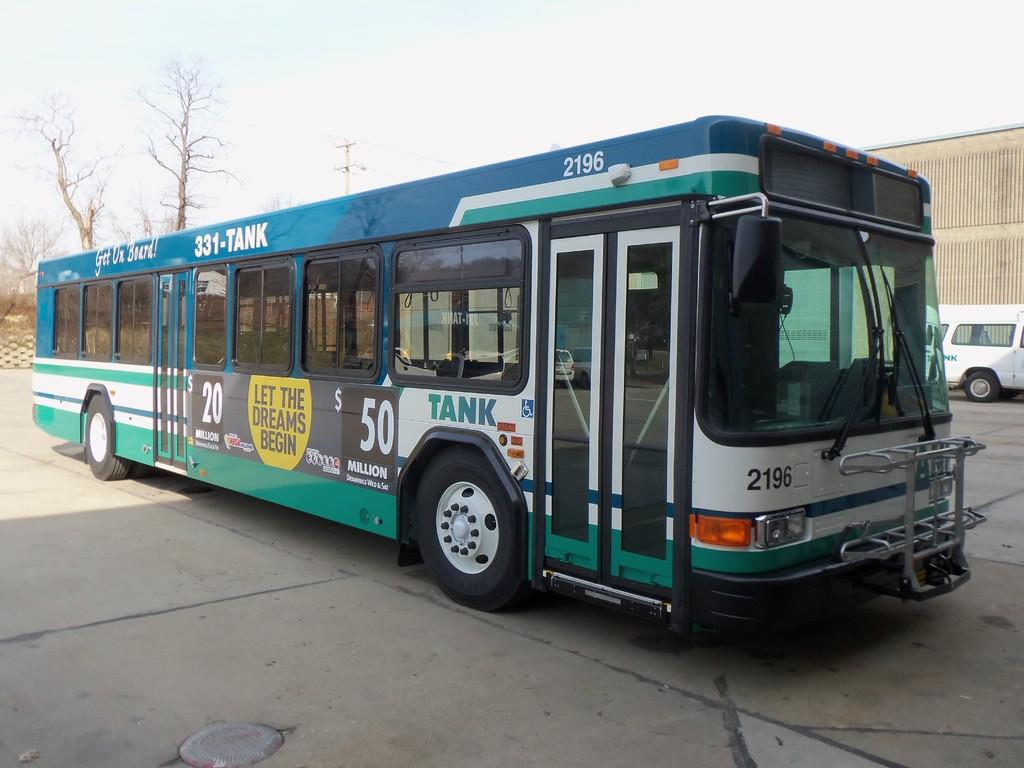What is the main subject of the image? The main subject of the image is a bus. What features can be seen on the bus? The bus has doors and windows. Is there any text or writing on the bus? Yes, there is writing on the bus. What can be seen in the background of the image? There are trees and the sky visible in the background of the image. What other vehicle is present in the image? There is a wall and a vehicle in the image. What type of spring is visible on the bus in the image? There is no spring present on the bus in the image. How can the wall be folded to create more space in the image? The wall cannot be folded in the image, as it is a solid structure. 